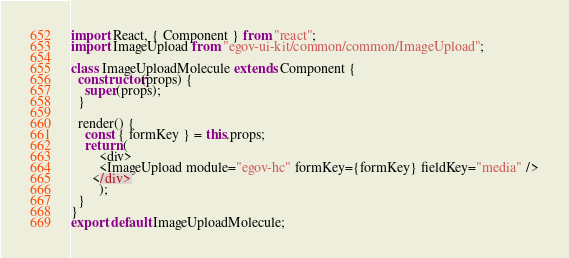Convert code to text. <code><loc_0><loc_0><loc_500><loc_500><_JavaScript_>import React, { Component } from "react";
import ImageUpload from "egov-ui-kit/common/common/ImageUpload";

class ImageUploadMolecule extends Component {
  constructor(props) {
    super(props);
  }

  render() {
    const { formKey } = this.props;
    return (
        <div>
        <ImageUpload module="egov-hc" formKey={formKey} fieldKey="media" />
      </div>
        );
  }
}
export default ImageUploadMolecule;
</code> 